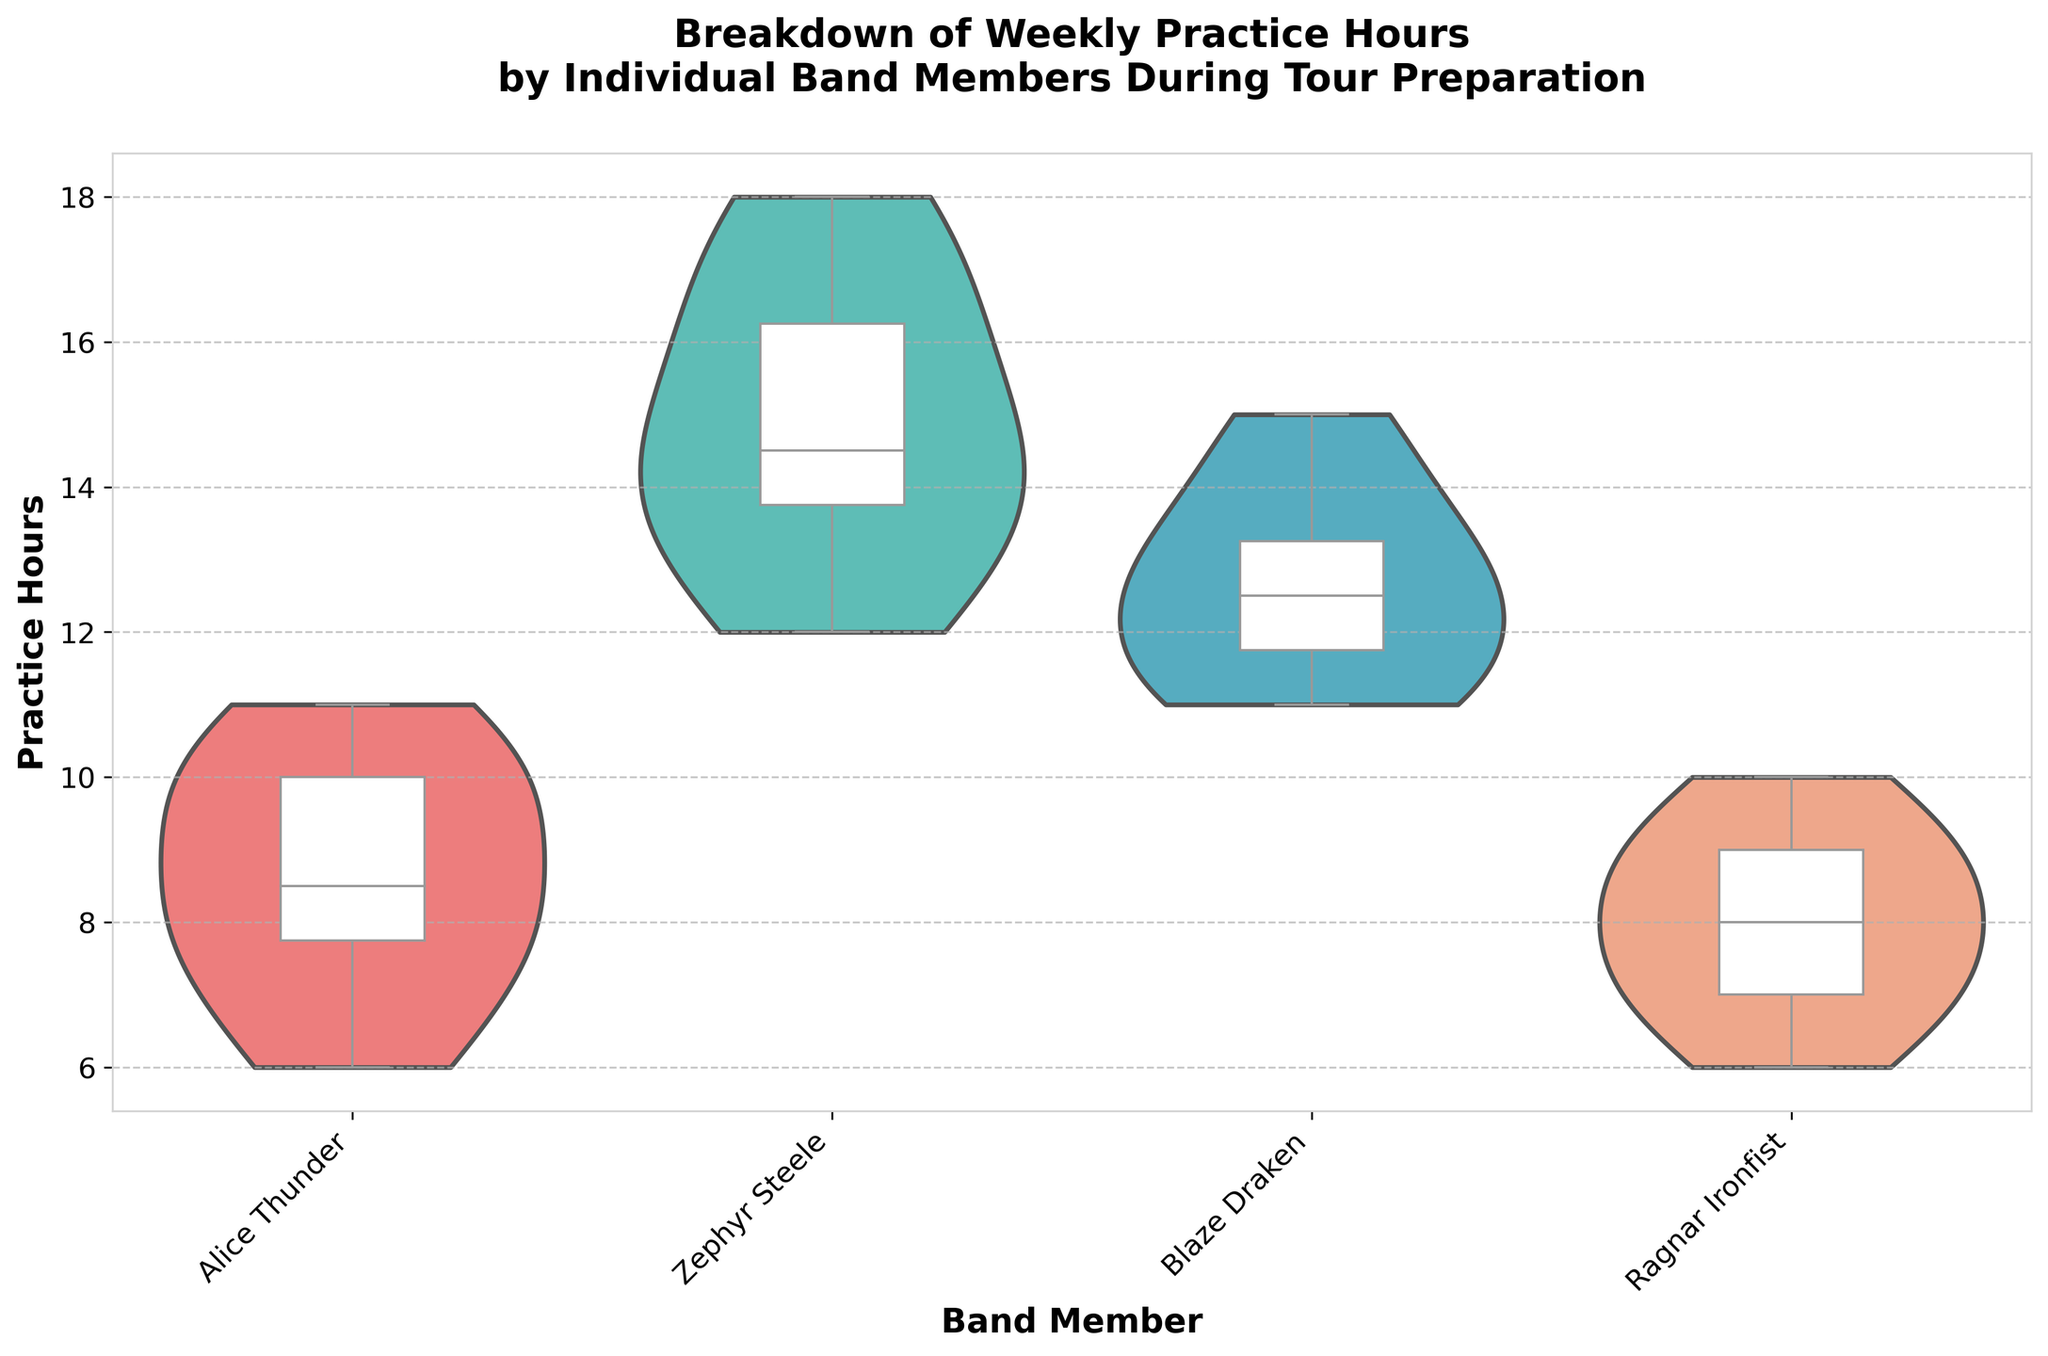What is the title of the chart? The title is often located at the top of the chart and provides a brief description of what the chart is about.
Answer: Breakdown of Weekly Practice Hours by Individual Band Members During Tour Preparation Which band member has the widest distribution of practice hours? The width of the violin plot reflects the distribution of data points; wider sections indicate more frequent practice hours.
Answer: Zephyr Steele What is the median practice time for Blaze Draken? The median is represented by the line inside the box of the box plot. For Blaze Draken, the median line can be seen inside the box.
Answer: 12.5 hours How does the median practice time of Alice Thunder compare with that of Ragnar Ironfist? The median practice time is the middle line inside the box plot for each respective band member. By comparing the medians of Alice Thunder and Ragnar Ironfist, we can see which is higher.
Answer: Alice Thunder's median is higher Which band member practices the least consistently? Inconsistency can be inferred from the overall spread and variance in the violin plot. A wider and less concentrated distribution indicates less consistent practice hours.
Answer: Zephyr Steele What is the interquartile range (IQR) for Ragnar Ironfist? The IQR is the range between the first quartile (25th percentile) and the third quartile (75th percentile) in the box plot. For Ragnar Ironfist, this range can be observed within the box.
Answer: 2 hours Which band member practices the most hours on average? You can find the average by considering the overall shape and center of the box plot. The higher the data concentrates near larger values, the higher the average practice hours.
Answer: Zephyr Steele How do the practice hours of Alice Thunder and Blaze Draken compare in terms of data spread? Compare the widths of the violin plots and the length of the whiskers in the box plots for both members. A larger spread indicates greater variance in practice hours.
Answer: Blaze Draken has a narrower spread, indicating less variance in practice hours What is the practice hour range for Zephyr Steele? The range is determined by the minimum and maximum points of the dataset, indicated by the ends of the violin plot or the whiskers of the box plot.
Answer: 12 to 18 hours 